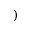Convert formula to latex. <formula><loc_0><loc_0><loc_500><loc_500>)</formula> 